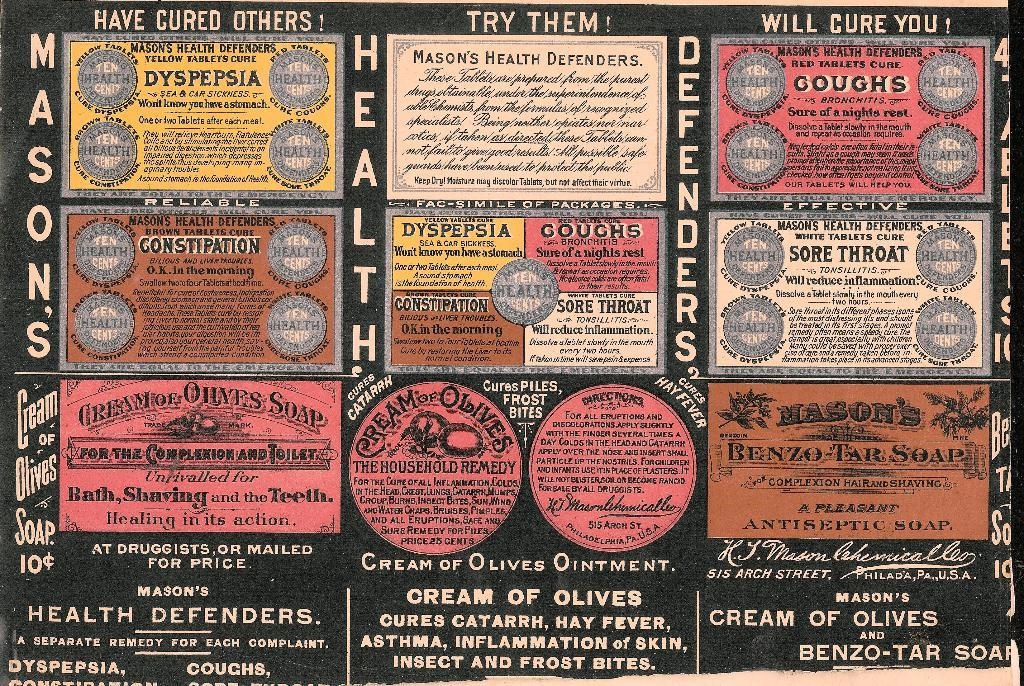<image>
Provide a brief description of the given image. Black psoter that says "Have Cured Others" on top. 